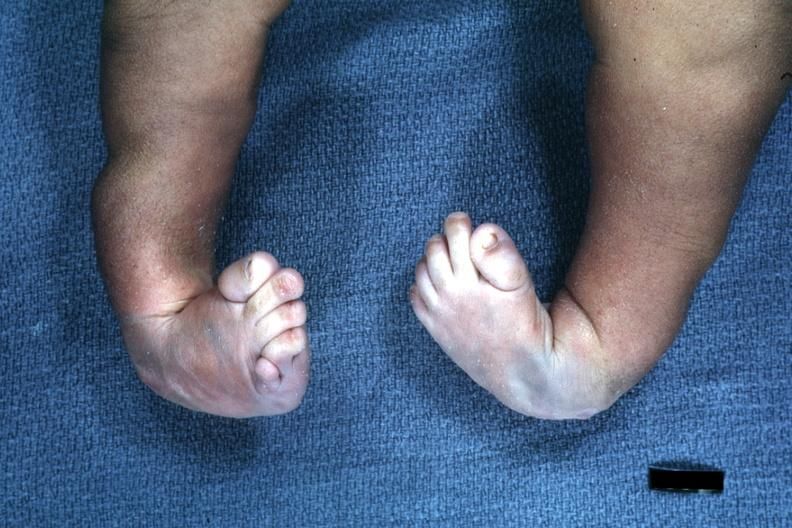re skin over back a buttocks present?
Answer the question using a single word or phrase. No 